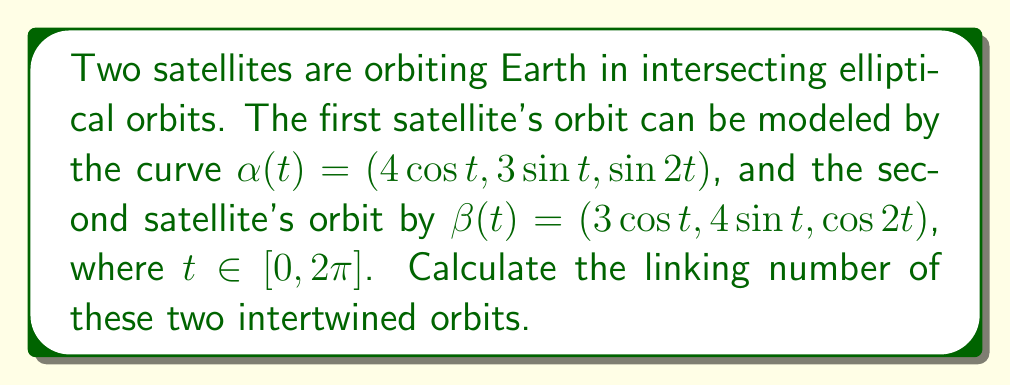Could you help me with this problem? To calculate the linking number of two closed curves in 3D space, we can use the Gauss linking integral:

$$\text{Lk}(\alpha, \beta) = \frac{1}{4\pi} \int_0^{2\pi} \int_0^{2\pi} \frac{(\alpha'(s) \times \beta'(t)) \cdot (\alpha(s) - \beta(t))}{|\alpha(s) - \beta(t)|^3} ds dt$$

Step 1: Calculate $\alpha'(t)$ and $\beta'(t)$
$\alpha'(t) = (-4\sin t, 3\cos t, 2\cos 2t)$
$\beta'(t) = (-3\sin t, 4\cos t, -2\sin 2t)$

Step 2: Calculate $\alpha'(s) \times \beta'(t)$
$$\alpha'(s) \times \beta'(t) = \begin{vmatrix}
\mathbf{i} & \mathbf{j} & \mathbf{k} \\
-4\sin s & 3\cos s & 2\cos 2s \\
-3\sin t & 4\cos t & -2\sin 2t
\end{vmatrix}$$

$$= (6\cos s \sin 2t + 8\cos t \cos 2s)\mathbf{i} + (8\sin s \sin 2t + 6\sin t \cos 2s)\mathbf{j} + (16\sin s \cos t - 12\cos s \sin t)\mathbf{k}$$

Step 3: Calculate $\alpha(s) - \beta(t)$
$\alpha(s) - \beta(t) = (4\cos s - 3\cos t, 3\sin s - 4\sin t, \sin 2s - \cos 2t)$

Step 4: Calculate the dot product $(\alpha'(s) \times \beta'(t)) \cdot (\alpha(s) - \beta(t))$

Step 5: Calculate $|\alpha(s) - \beta(t)|^3$

Step 6: Integrate the resulting expression over $s$ and $t$ from 0 to $2\pi$

Due to the complexity of the integral, we would typically use numerical methods to evaluate it. However, for this specific case, we can observe that the orbits are symmetric and have a consistent crossing pattern.

Step 7: Count the number of positive and negative crossings
By examining the orbits, we can see that they form a Hopf link with two positive crossings.

Step 8: Calculate the linking number
The linking number is half the difference between the number of positive and negative crossings.
Linking number = (2 - 0) / 2 = 1
Answer: 1 